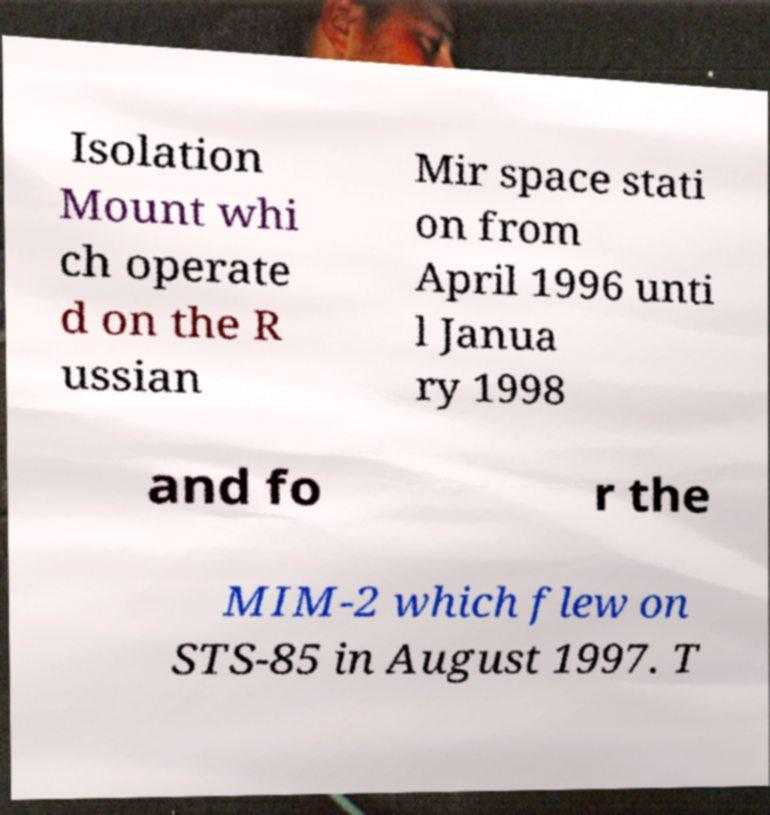For documentation purposes, I need the text within this image transcribed. Could you provide that? Isolation Mount whi ch operate d on the R ussian Mir space stati on from April 1996 unti l Janua ry 1998 and fo r the MIM-2 which flew on STS-85 in August 1997. T 